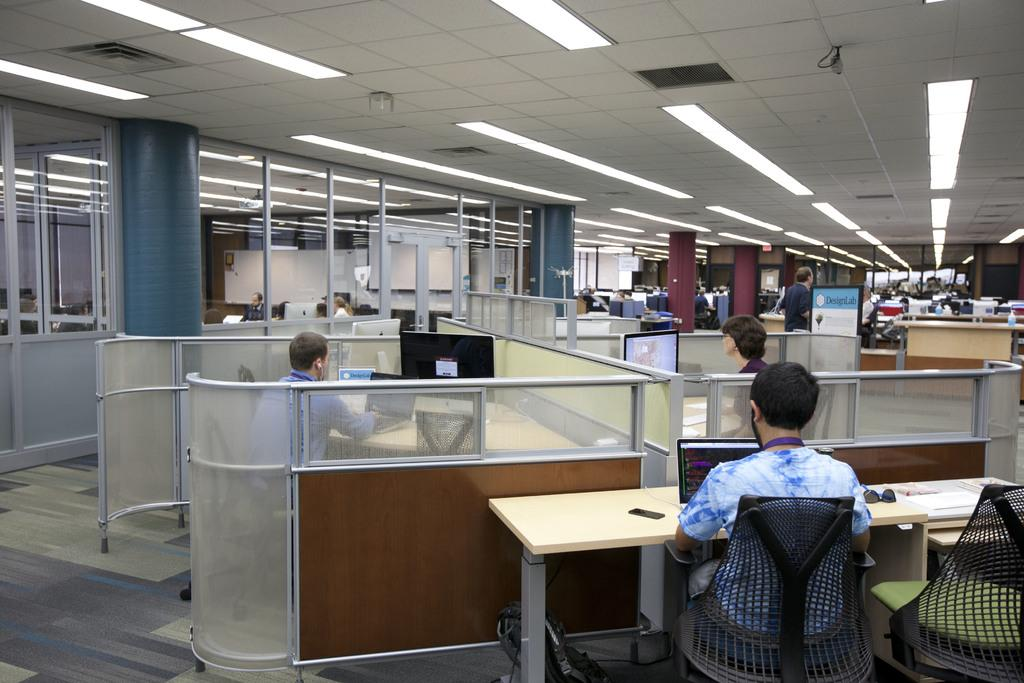What type of environment is shown in the image? The image depicts an office setting. What are the people in the image doing? They are working at their desks. What tools are they using to work? They are using desktop computers. What can be seen above the desks in the image? There is a ceiling visible in the image, and lights are present between the ceiling and the desks. Are there any dolls sitting on the desks in the image? No, there are no dolls present in the image. Can you see an airplane flying through the office in the image? No, there is no airplane visible in the image. 